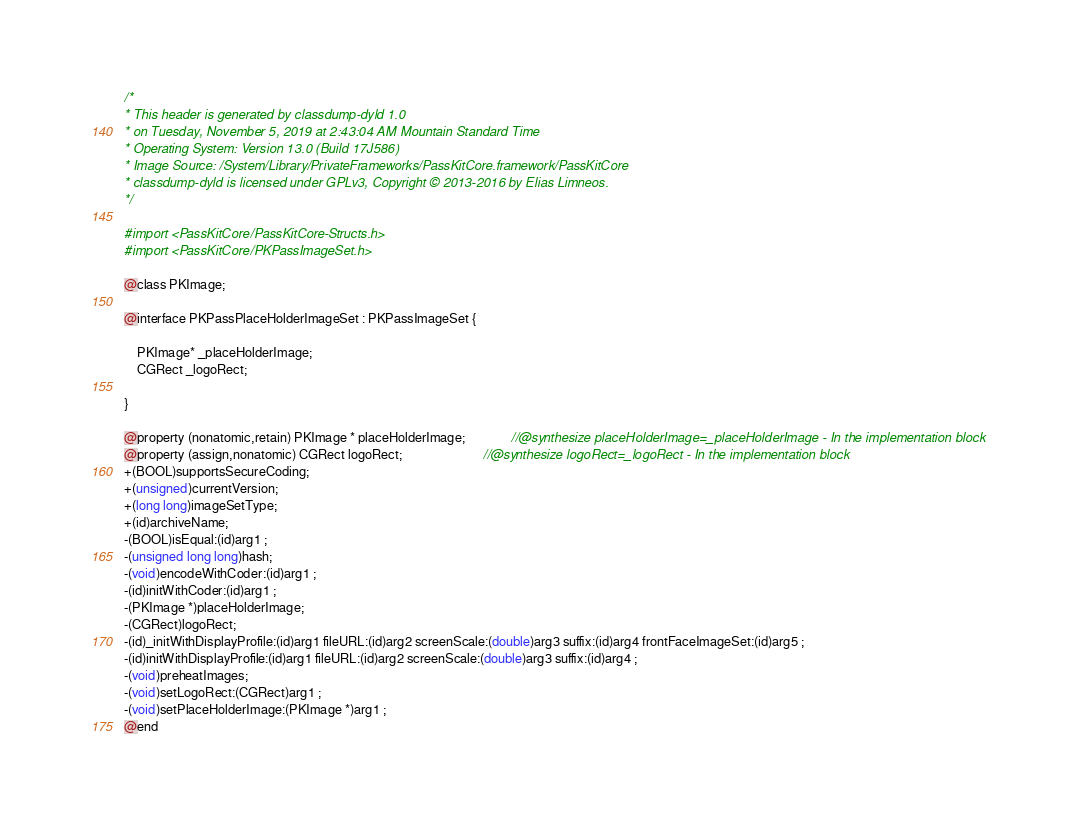Convert code to text. <code><loc_0><loc_0><loc_500><loc_500><_C_>/*
* This header is generated by classdump-dyld 1.0
* on Tuesday, November 5, 2019 at 2:43:04 AM Mountain Standard Time
* Operating System: Version 13.0 (Build 17J586)
* Image Source: /System/Library/PrivateFrameworks/PassKitCore.framework/PassKitCore
* classdump-dyld is licensed under GPLv3, Copyright © 2013-2016 by Elias Limneos.
*/

#import <PassKitCore/PassKitCore-Structs.h>
#import <PassKitCore/PKPassImageSet.h>

@class PKImage;

@interface PKPassPlaceHolderImageSet : PKPassImageSet {

	PKImage* _placeHolderImage;
	CGRect _logoRect;

}

@property (nonatomic,retain) PKImage * placeHolderImage;              //@synthesize placeHolderImage=_placeHolderImage - In the implementation block
@property (assign,nonatomic) CGRect logoRect;                         //@synthesize logoRect=_logoRect - In the implementation block
+(BOOL)supportsSecureCoding;
+(unsigned)currentVersion;
+(long long)imageSetType;
+(id)archiveName;
-(BOOL)isEqual:(id)arg1 ;
-(unsigned long long)hash;
-(void)encodeWithCoder:(id)arg1 ;
-(id)initWithCoder:(id)arg1 ;
-(PKImage *)placeHolderImage;
-(CGRect)logoRect;
-(id)_initWithDisplayProfile:(id)arg1 fileURL:(id)arg2 screenScale:(double)arg3 suffix:(id)arg4 frontFaceImageSet:(id)arg5 ;
-(id)initWithDisplayProfile:(id)arg1 fileURL:(id)arg2 screenScale:(double)arg3 suffix:(id)arg4 ;
-(void)preheatImages;
-(void)setLogoRect:(CGRect)arg1 ;
-(void)setPlaceHolderImage:(PKImage *)arg1 ;
@end

</code> 